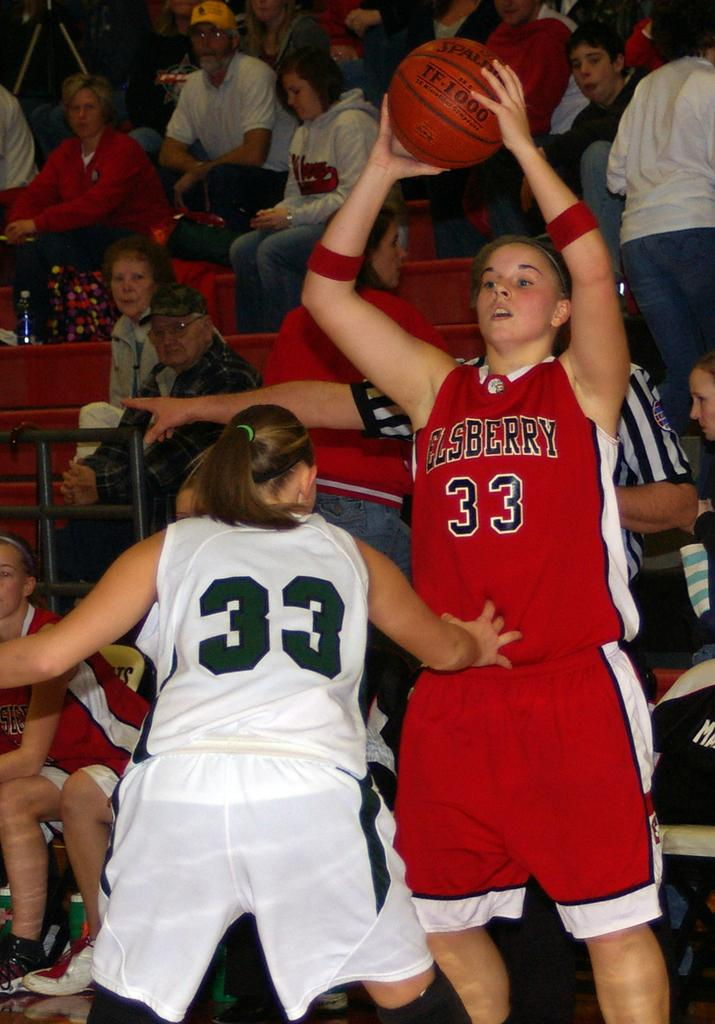<image>
Describe the image concisely. The basketball opponents have the same uniform number, 33. 